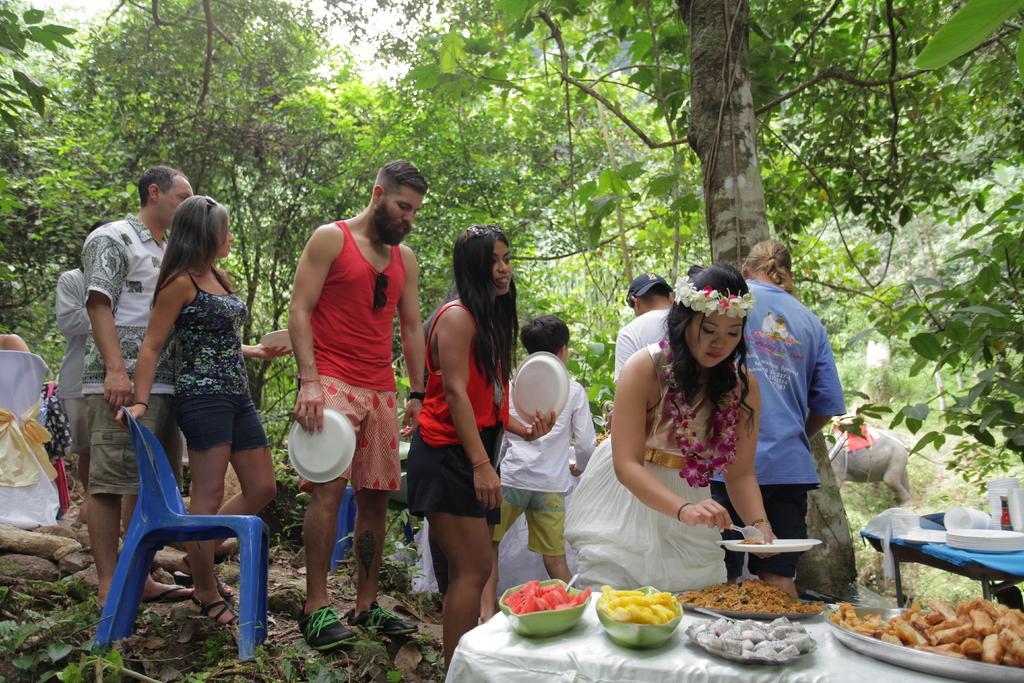Please provide a concise description of this image. In this picture there are a group of people standing, one of them is serving food in the plate, the food served here in the plates on the table and in the background there is a tree the plants, there is a chair over here and there are some trees and stones on the floor and the sky is clear. 